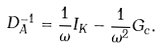Convert formula to latex. <formula><loc_0><loc_0><loc_500><loc_500>{ D } _ { A } ^ { - 1 } = \frac { 1 } { \omega } { I } _ { K } - \frac { 1 } { \omega ^ { 2 } } { G } _ { c } .</formula> 